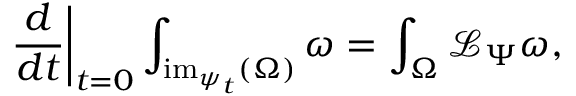<formula> <loc_0><loc_0><loc_500><loc_500>{ \frac { d } { d t } } \right | _ { t = 0 } \int _ { { i m } _ { \psi _ { t } } ( \Omega ) } \omega = \int _ { \Omega } { \mathcal { L } } _ { \Psi } \omega ,</formula> 